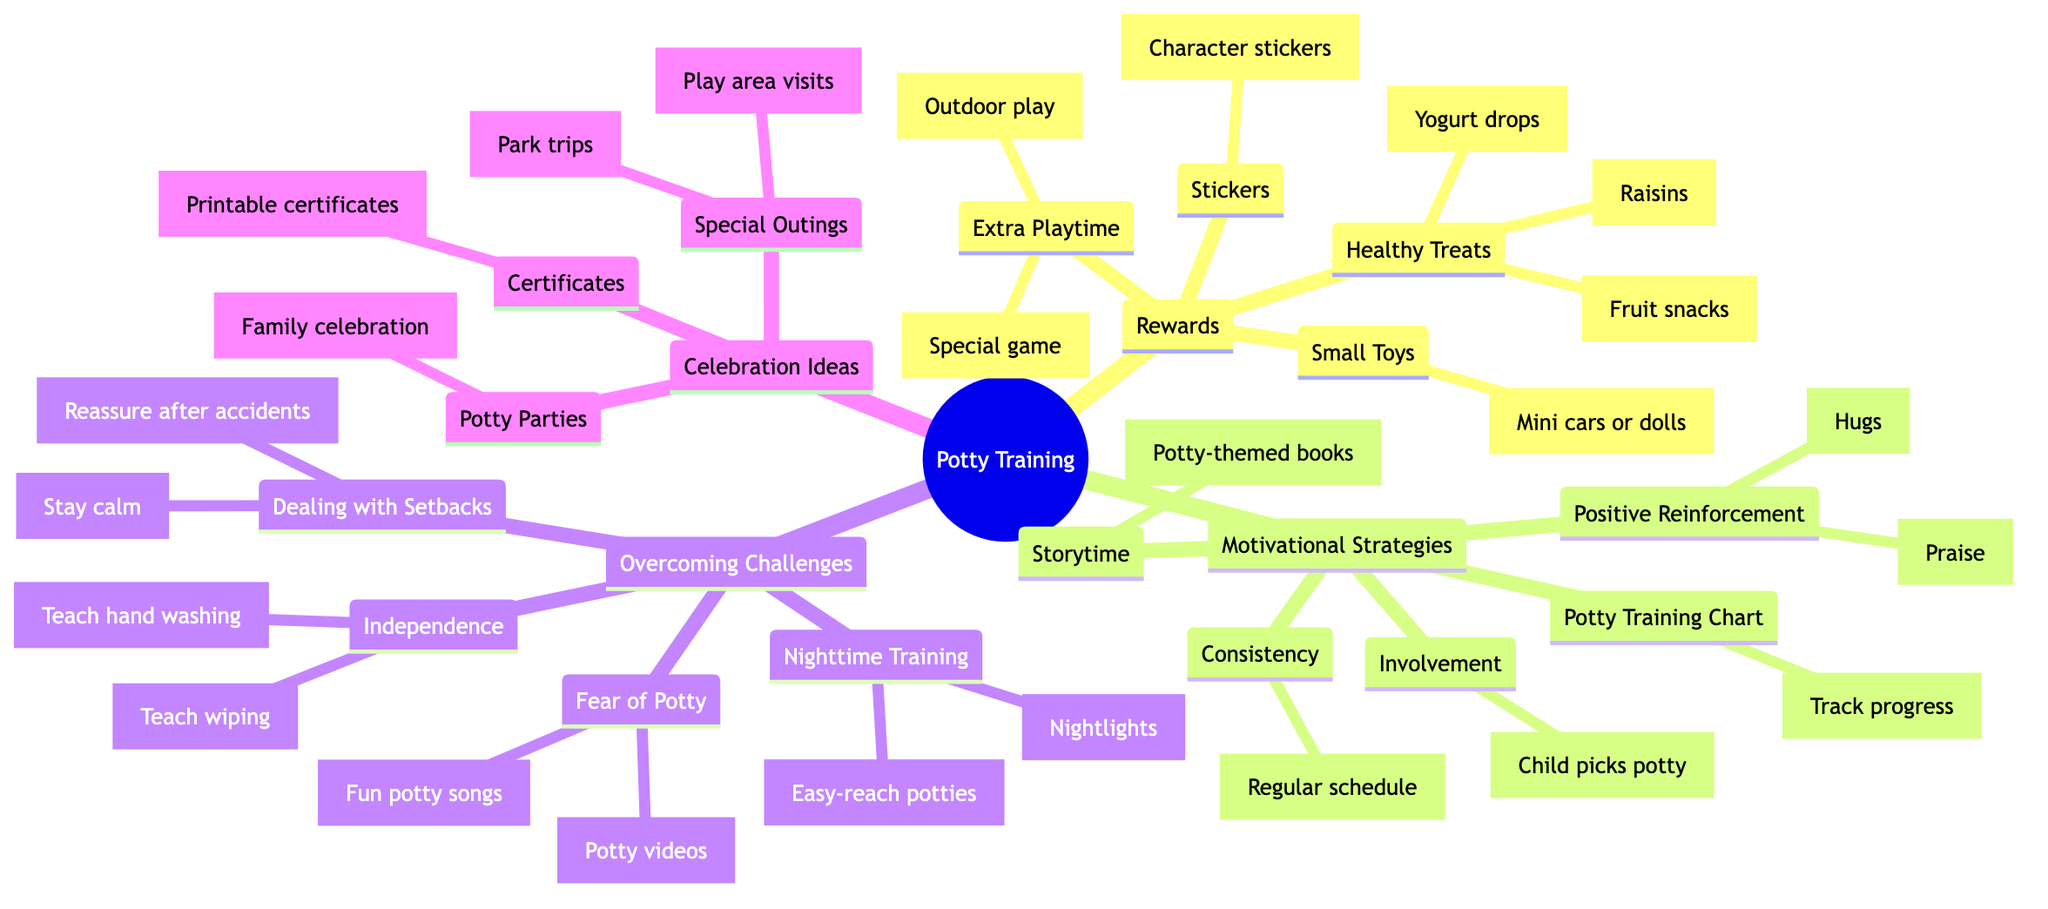What types of rewards are included? The root node lists "Types of Rewards" as a main category. Under this category, there are four sub-nodes: "Stickers," "Small Toys," "Healthy Treats," and "Extra Playtime."
Answer: Stickers, Small Toys, Healthy Treats, Extra Playtime How many motivational strategies are there? The "Motivational Strategies" node has five sub-nodes listed: "Positive Reinforcement," "Consistency," "Involvement," "Storytime," and "Potty Training Chart." Therefore, the count is five.
Answer: 5 What is an example of a healthy treat? Under the "Healthy Treats" node, examples given are "Fruit snacks," "Yogurt drops," and "Raisins." You can reply with one of these examples.
Answer: Fruit snacks How can one encourage independence in potty training? The "Independence Encouragement" node falls under "Overcoming Challenges" and details methods for fostering independence like "Teaching them to wipe" and "Teaching them to wash hands."
Answer: Teach wiping, Teach hand washing Which category includes potty parties? The "Celebration Ideas" node contains "Potty Parties" as one of its sub-nodes, indicating that it belongs to this category of celebrations.
Answer: Celebration Ideas What should be done when facing setbacks? The "Dealing with Setbacks" node suggests two strategies: "Staying calm" and "Reassuring after accidents," indicating these are key actions to take.
Answer: Stay calm, Reassure after accidents How do you create a potty training chart? The "Potty Training Chart" node suggests tracking progress with stars or stickers, which is the suggested action for this strategy.
Answer: Track progress with stars or stickers What are the two strategies used for nighttime training? The "Nighttime Training" node provides two methods: "Using nightlights" and "Easy-reach potties," indicating these should be implemented for successful nighttime training.
Answer: Nightlights, Easy-reach potties How many main categories are there in this mind map? The mind map shows four main categories: "Types of Rewards," "Motivational Strategies," "Overcoming Challenges," and "Celebration Ideas," summing up to four distinct categories.
Answer: 4 